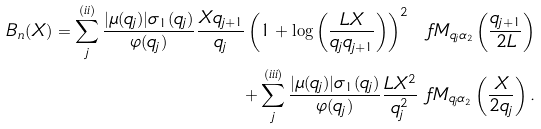<formula> <loc_0><loc_0><loc_500><loc_500>B _ { n } ( X ) = \sum ^ { ( i i ) } _ { j } \frac { | \mu ( q _ { j } ) | \sigma _ { 1 } ( q _ { j } ) } { \varphi ( q _ { j } ) } \frac { X q _ { j + 1 } } { q _ { j } } \left ( 1 + \log \left ( \frac { L X } { q _ { j } q _ { j + 1 } } \right ) \right ) ^ { 2 } \ f M _ { q _ { j } \alpha _ { 2 } } \left ( \frac { q _ { j + 1 } } { 2 L } \right ) \\ + \sum ^ { ( i i i ) } _ { j } \frac { | \mu ( q _ { j } ) | \sigma _ { 1 } ( q _ { j } ) } { \varphi ( q _ { j } ) } \frac { L X ^ { 2 } } { q _ { j } ^ { 2 } } \ f M _ { q _ { j } \alpha _ { 2 } } \left ( \frac { X } { 2 q _ { j } } \right ) .</formula> 